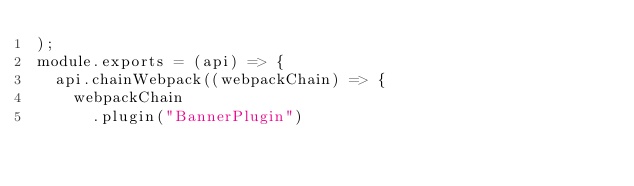Convert code to text. <code><loc_0><loc_0><loc_500><loc_500><_JavaScript_>);
module.exports = (api) => {
  api.chainWebpack((webpackChain) => {
    webpackChain
      .plugin("BannerPlugin")</code> 